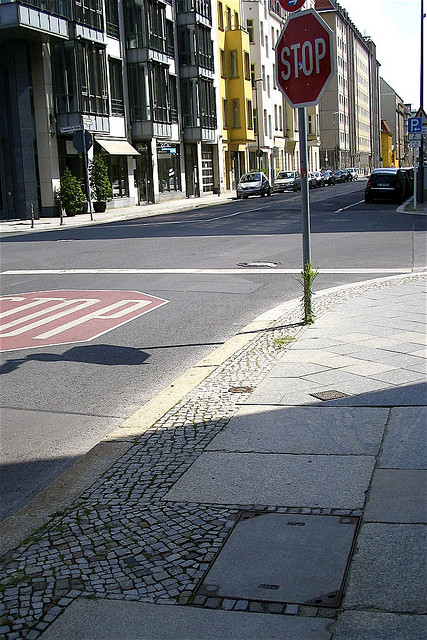<image>What sign is shown across the street past the stop sign? I am not sure what sign is shown across the street past the stop sign. It could be a parking sign or a bus sign. What sign is shown across the street past the stop sign? I am not sure what sign is shown across the street past the stop sign. It can be a parking sign or a bus sign. 